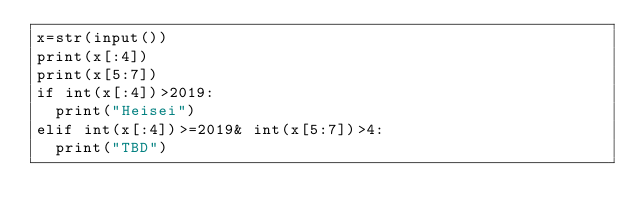Convert code to text. <code><loc_0><loc_0><loc_500><loc_500><_Python_>x=str(input())
print(x[:4])
print(x[5:7])
if int(x[:4])>2019:
  print("Heisei")
elif int(x[:4])>=2019& int(x[5:7])>4:
  print("TBD")
  </code> 